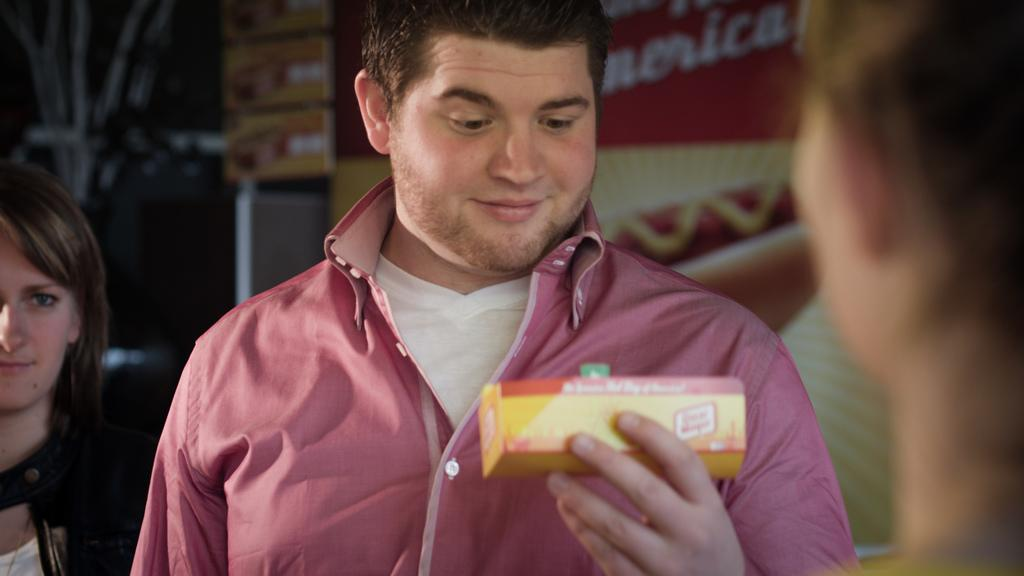Who is the main subject in the image? There is a man in the center of the image. What is the man holding in the image? The man is holding a box. Can you describe the background of the image? There are other people and a board visible in the background of the image. What type of chain is the man wearing in the image? There is no chain visible on the man in the image. How many clams can be seen on the board in the background of the image? There are no clams present in the image; only a board is visible in the background. 